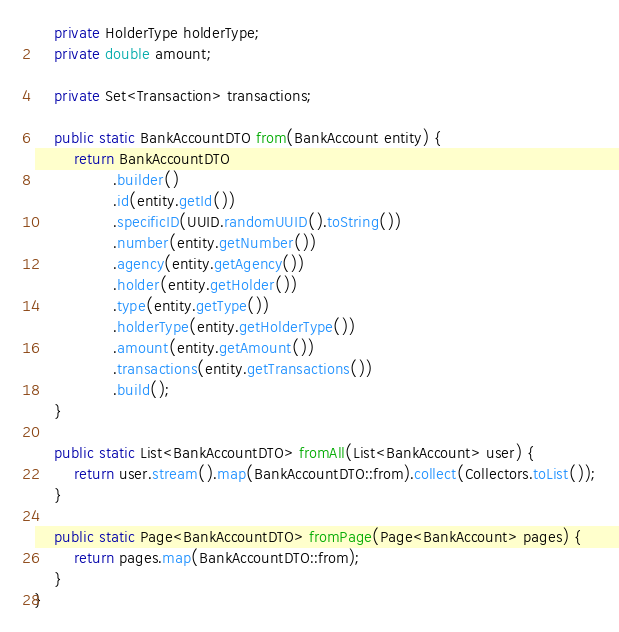Convert code to text. <code><loc_0><loc_0><loc_500><loc_500><_Java_>    private HolderType holderType;
    private double amount;

    private Set<Transaction> transactions;

    public static BankAccountDTO from(BankAccount entity) {
        return BankAccountDTO
                .builder()
                .id(entity.getId())
                .specificID(UUID.randomUUID().toString())
                .number(entity.getNumber())
                .agency(entity.getAgency())
                .holder(entity.getHolder())
                .type(entity.getType())
                .holderType(entity.getHolderType())
                .amount(entity.getAmount())
                .transactions(entity.getTransactions())
                .build();
    }

    public static List<BankAccountDTO> fromAll(List<BankAccount> user) {
        return user.stream().map(BankAccountDTO::from).collect(Collectors.toList());
    }

    public static Page<BankAccountDTO> fromPage(Page<BankAccount> pages) {
        return pages.map(BankAccountDTO::from);
    }
}
</code> 